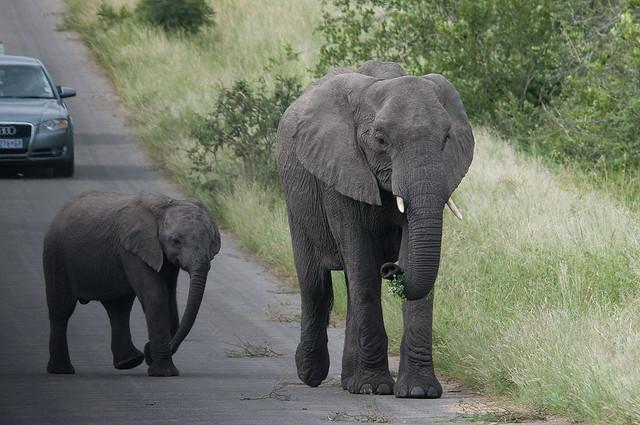What make of car is behind the elephants? Please explain your reasoning. audi. There is a logo on the front of the car. it has four rings. 